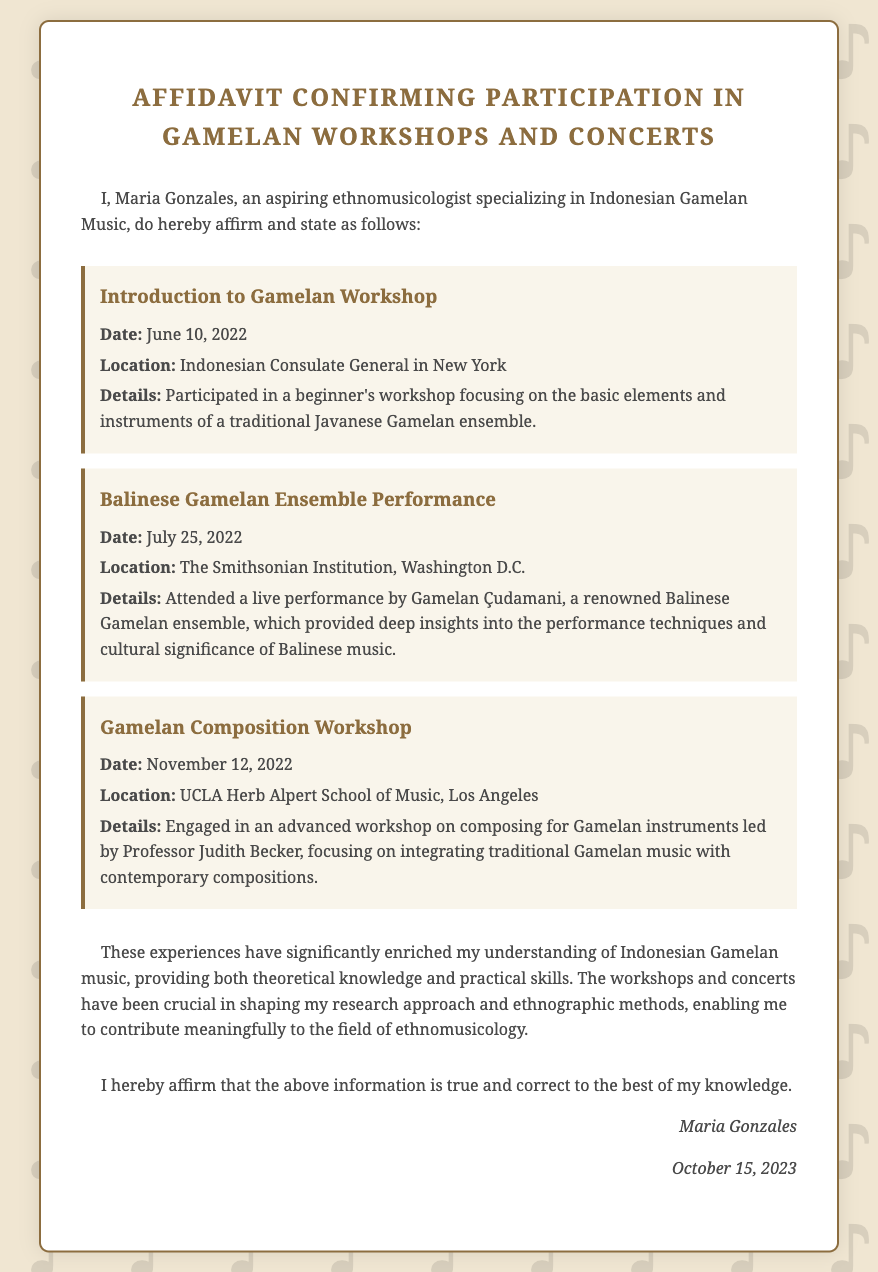What is the name of the individual affirming participation? The document states that the individual affirming participation is Maria Gonzales.
Answer: Maria Gonzales What is the date of the Introduction to Gamelan Workshop? The specific date mentioned for the Introduction to Gamelan Workshop is June 10, 2022.
Answer: June 10, 2022 Where was the Balinese Gamelan Ensemble Performance held? The location for the Balinese Gamelan Ensemble Performance is specified as The Smithsonian Institution, Washington D.C.
Answer: The Smithsonian Institution, Washington D.C Who led the Gamelan Composition Workshop? The document indicates that Professor Judith Becker led the Gamelan Composition Workshop.
Answer: Professor Judith Becker What is the overall impact of the workshops on the individual? The individual reflects that the experiences have significantly enriched their understanding of Indonesian Gamelan music.
Answer: Enriched understanding How many events are listed in the affidavit? The document lists a total of three events in the affidavit.
Answer: Three On what date was this affidavit signed? The affidavit was signed on October 15, 2023, as indicated in the document.
Answer: October 15, 2023 What type of music does Maria Gonzales specialize in? The affidavit states that Maria Gonzales specializes in Indonesian Gamelan Music.
Answer: Indonesian Gamelan Music 